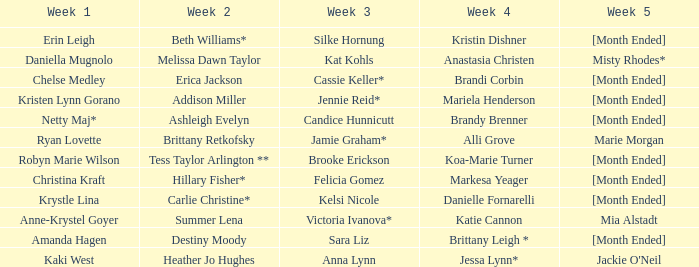What is the week 3 with addison miller in week 2? Jennie Reid*. 